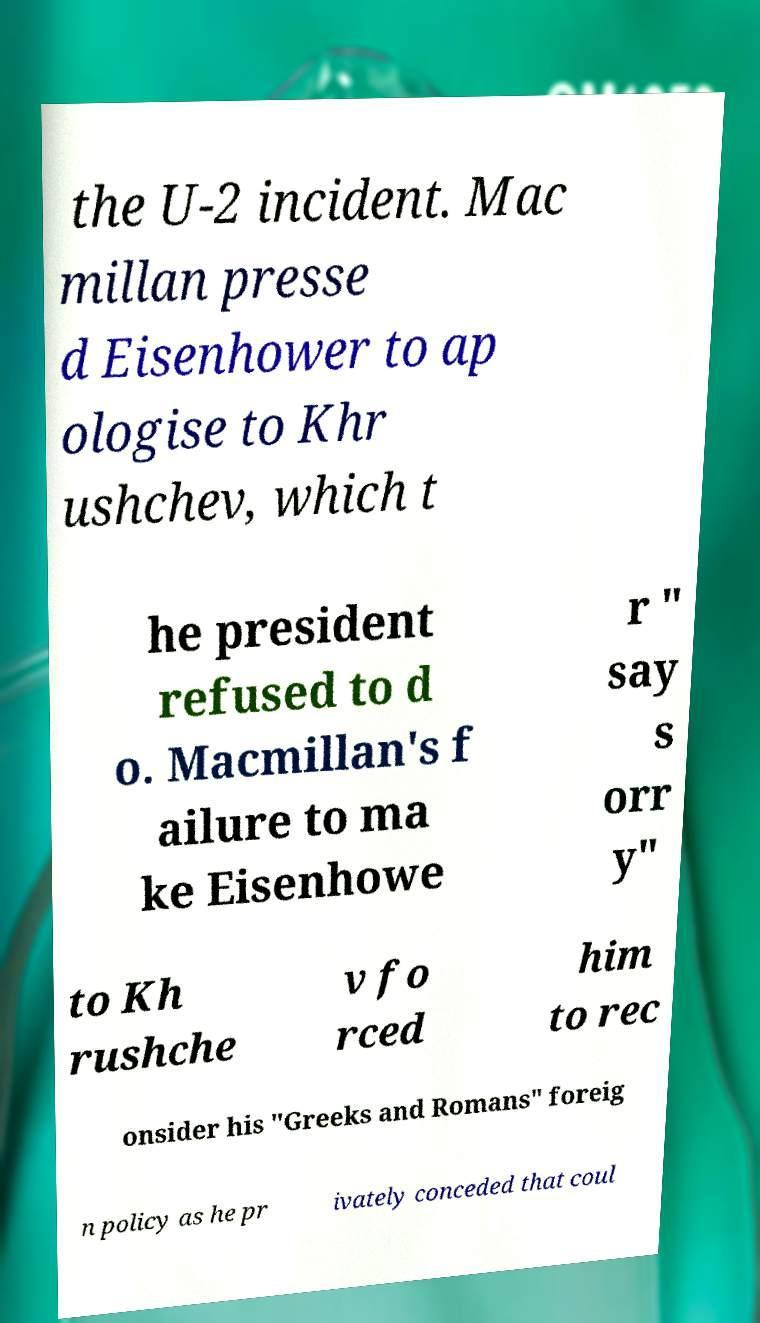For documentation purposes, I need the text within this image transcribed. Could you provide that? the U-2 incident. Mac millan presse d Eisenhower to ap ologise to Khr ushchev, which t he president refused to d o. Macmillan's f ailure to ma ke Eisenhowe r " say s orr y" to Kh rushche v fo rced him to rec onsider his "Greeks and Romans" foreig n policy as he pr ivately conceded that coul 